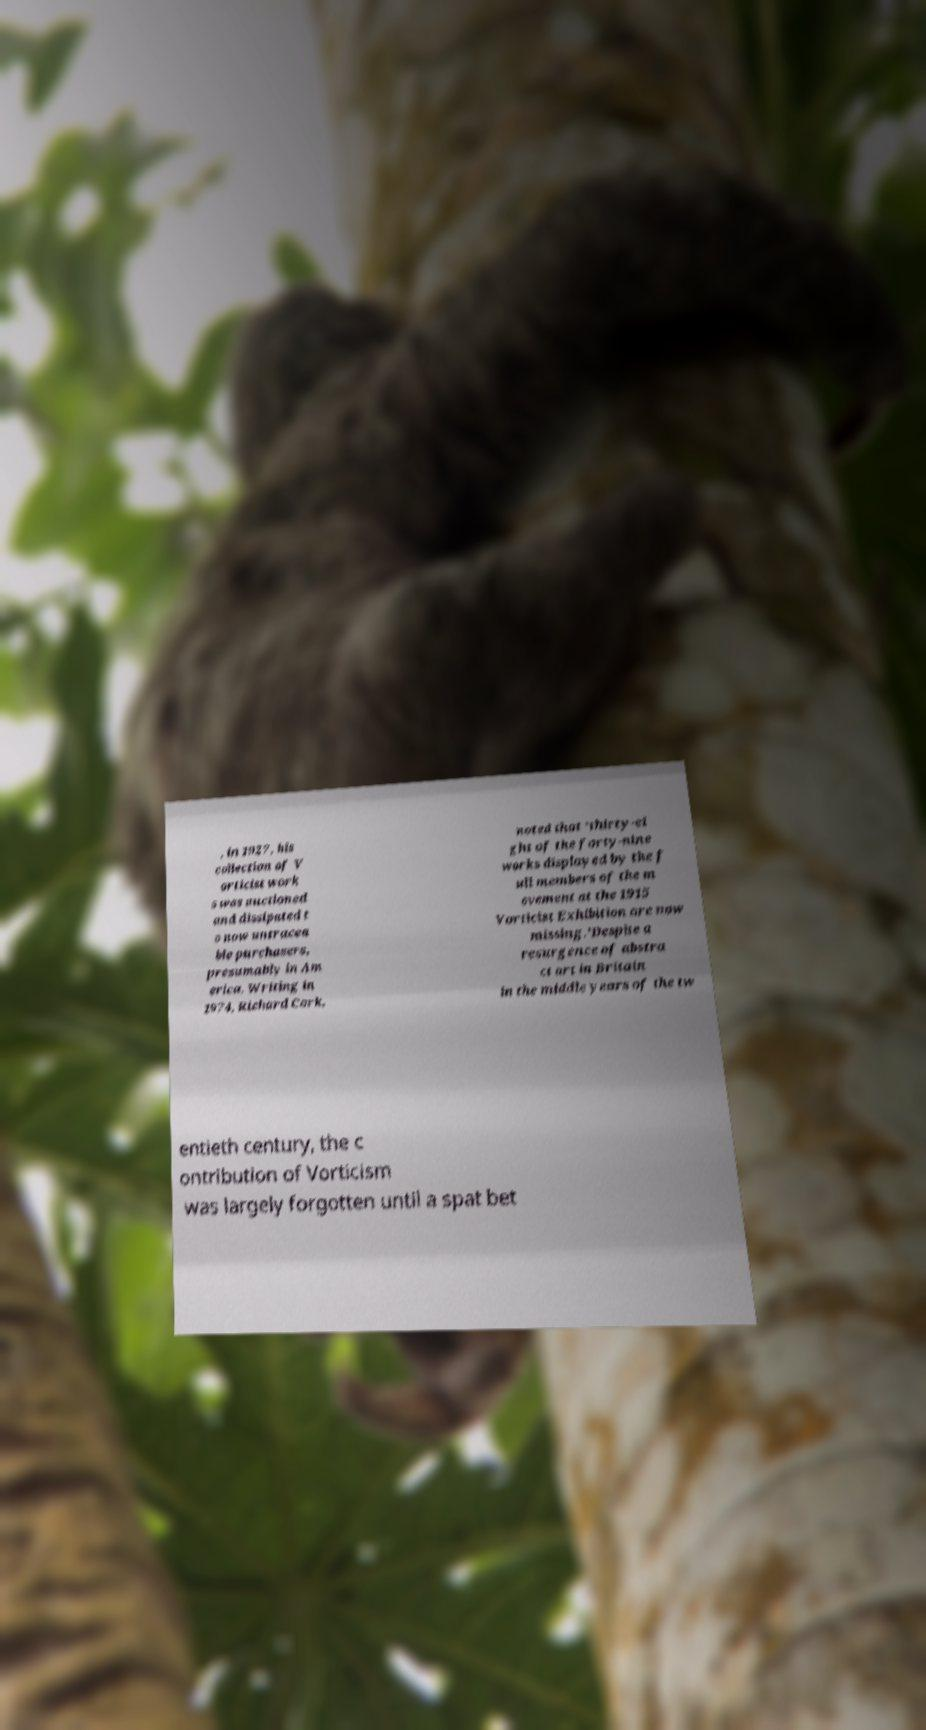Can you read and provide the text displayed in the image?This photo seems to have some interesting text. Can you extract and type it out for me? , in 1927, his collection of V orticist work s was auctioned and dissipated t o now untracea ble purchasers, presumably in Am erica. Writing in 1974, Richard Cork, noted that 'thirty-ei ght of the forty-nine works displayed by the f ull members of the m ovement at the 1915 Vorticist Exhibition are now missing.'Despite a resurgence of abstra ct art in Britain in the middle years of the tw entieth century, the c ontribution of Vorticism was largely forgotten until a spat bet 